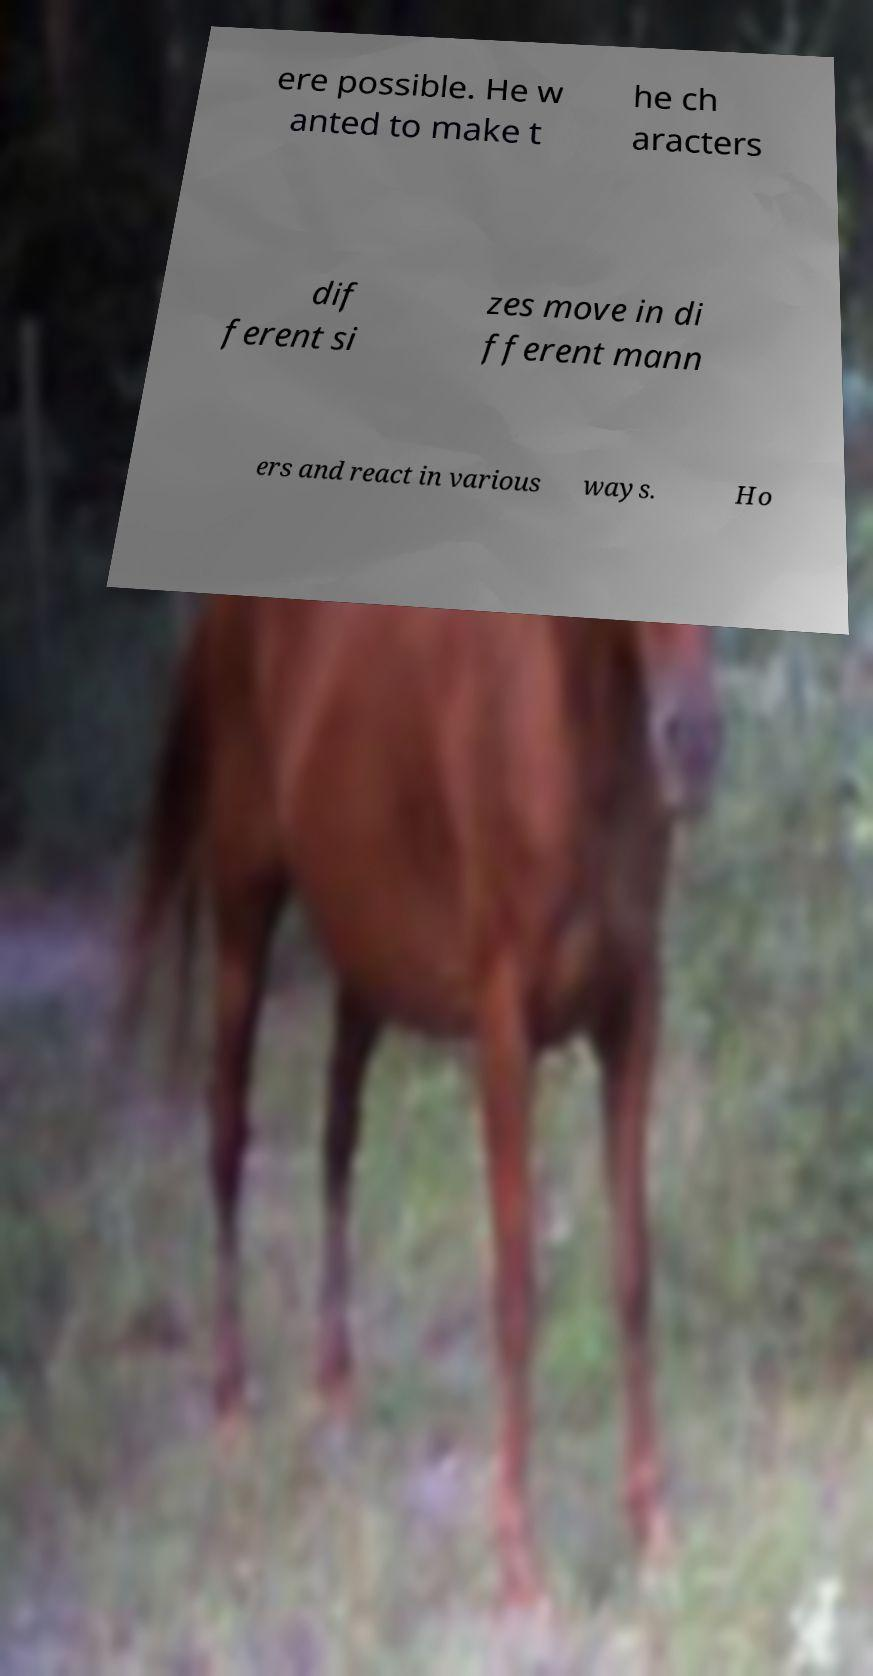I need the written content from this picture converted into text. Can you do that? ere possible. He w anted to make t he ch aracters dif ferent si zes move in di fferent mann ers and react in various ways. Ho 